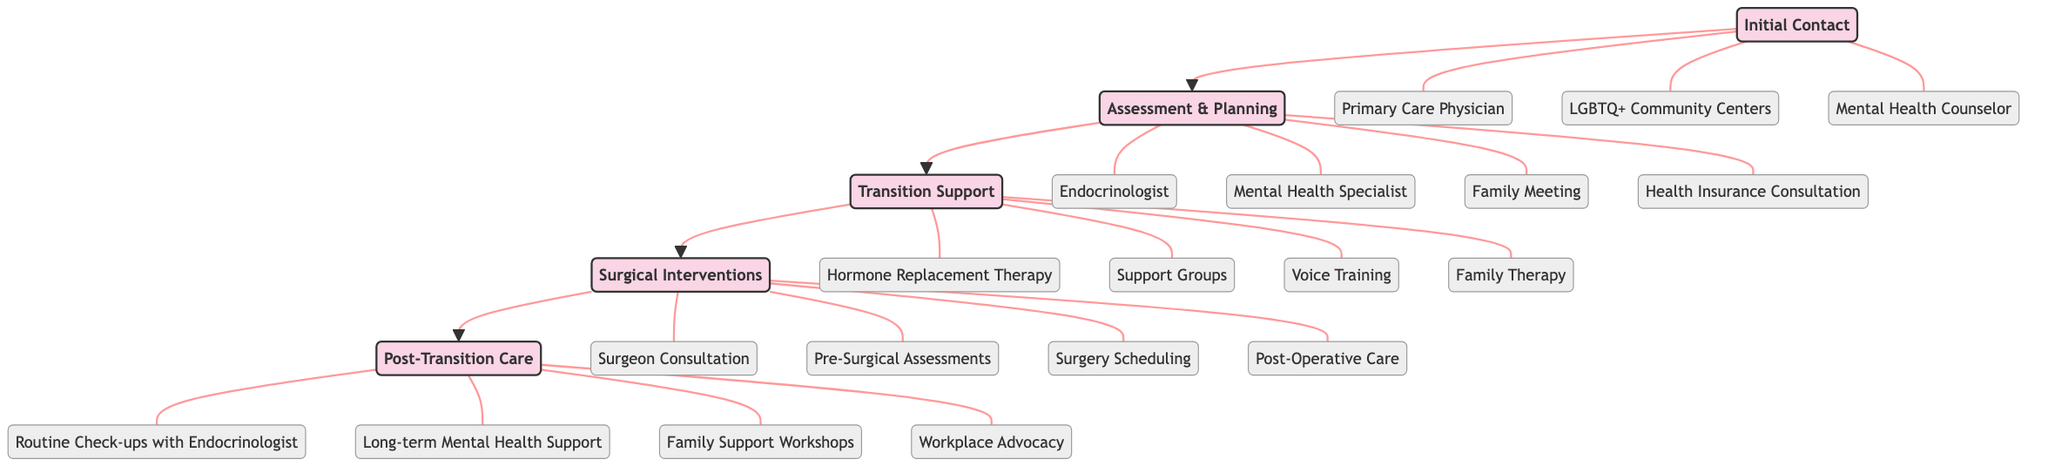What is the first stage of the Clinical Pathway? According to the diagram, the first stage listed in the Clinical Pathway is "Initial Contact".
Answer: Initial Contact How many elements are there in the Transition Support stage? The Transition Support stage has four elements listed: Hormone Replacement Therapy, Support Groups, Voice Training, and Family Therapy, making a total of four elements.
Answer: 4 What element is associated with the Assessment & Planning stage that involves discussion with family? The element that involves discussion with family in the Assessment & Planning stage is "Family Meeting".
Answer: Family Meeting Which stage follows the Surgical Interventions stage? The diagram details that the stage that follows Surgical Interventions is "Post-Transition Care".
Answer: Post-Transition Care How many total stages are present in the Clinical Pathway? There are five stages in total in the Clinical Pathway: Initial Contact, Assessment & Planning, Transition Support, Surgical Interventions, and Post-Transition Care, resulting in a total of five stages.
Answer: 5 What is a common support element found in both the Transition Support and Post-Transition Care stages? "Family Therapy" is the common support element found in the Transition Support stage, whereas "Family Support Workshops" is found in the Post-Transition Care stage. Thus, although they are different, both stages emphasize family involvement.
Answer: Family Therapy and Family Support Workshops What type of specialist is involved in both the Assessment & Planning and Post-Transition Care stages? "Mental Health Specialist" is the type of specialist that is involved in the Assessment & Planning stage, whereas "Long-term Mental Health Support" is present in the Post-Transition Care stage, indicating the continuous role of mental health professionals.
Answer: Mental Health Specialist Which stage contains the element regarding health insurance? The "Assessment & Planning" stage contains the element regarding health insurance, specifically referred to as "Health Insurance Consultation".
Answer: Assessment & Planning What element assists with post-operative recovery? The element that assists with post-operative recovery in the Surgical Interventions stage is "Post-Operative Care".
Answer: Post-Operative Care 